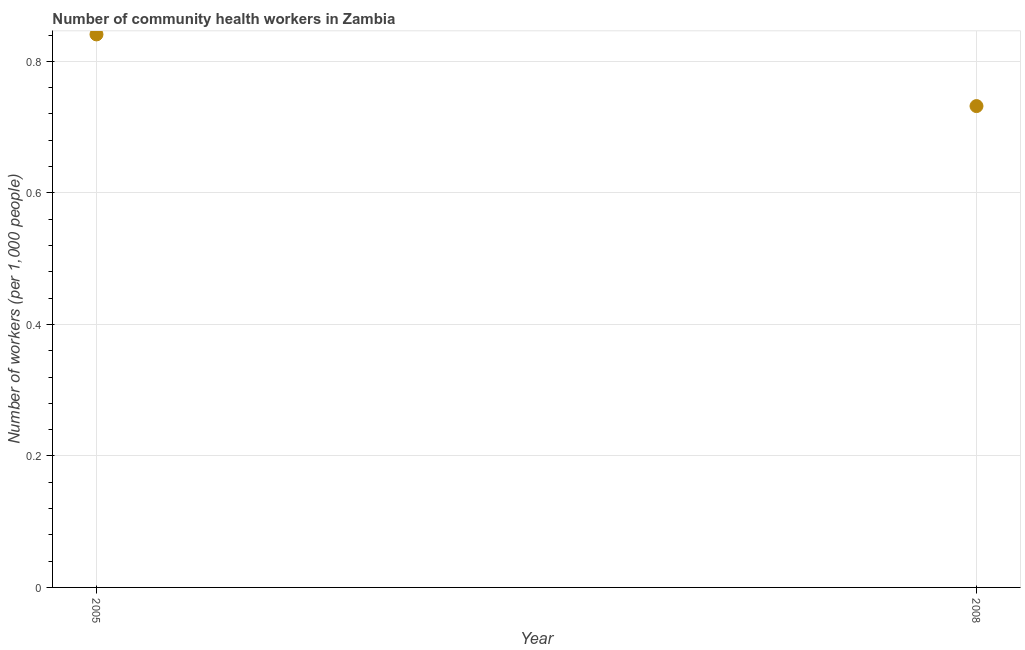What is the number of community health workers in 2005?
Your answer should be compact. 0.84. Across all years, what is the maximum number of community health workers?
Keep it short and to the point. 0.84. Across all years, what is the minimum number of community health workers?
Your answer should be compact. 0.73. In which year was the number of community health workers maximum?
Give a very brief answer. 2005. In which year was the number of community health workers minimum?
Offer a very short reply. 2008. What is the sum of the number of community health workers?
Provide a short and direct response. 1.57. What is the difference between the number of community health workers in 2005 and 2008?
Keep it short and to the point. 0.11. What is the average number of community health workers per year?
Provide a succinct answer. 0.79. What is the median number of community health workers?
Make the answer very short. 0.79. Do a majority of the years between 2005 and 2008 (inclusive) have number of community health workers greater than 0.08 ?
Ensure brevity in your answer.  Yes. What is the ratio of the number of community health workers in 2005 to that in 2008?
Your answer should be compact. 1.15. How many dotlines are there?
Ensure brevity in your answer.  1. How many years are there in the graph?
Offer a very short reply. 2. Are the values on the major ticks of Y-axis written in scientific E-notation?
Offer a very short reply. No. Does the graph contain any zero values?
Keep it short and to the point. No. What is the title of the graph?
Ensure brevity in your answer.  Number of community health workers in Zambia. What is the label or title of the X-axis?
Offer a terse response. Year. What is the label or title of the Y-axis?
Offer a very short reply. Number of workers (per 1,0 people). What is the Number of workers (per 1,000 people) in 2005?
Provide a short and direct response. 0.84. What is the Number of workers (per 1,000 people) in 2008?
Give a very brief answer. 0.73. What is the difference between the Number of workers (per 1,000 people) in 2005 and 2008?
Provide a short and direct response. 0.11. What is the ratio of the Number of workers (per 1,000 people) in 2005 to that in 2008?
Give a very brief answer. 1.15. 